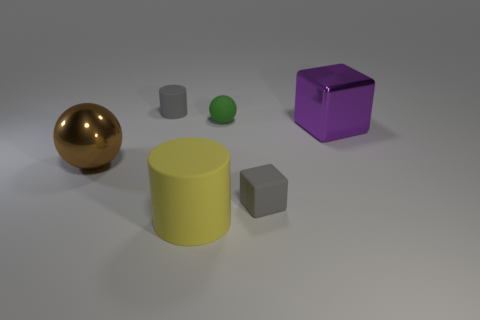Add 2 large yellow cylinders. How many objects exist? 8 Subtract all spheres. How many objects are left? 4 Subtract 0 red cubes. How many objects are left? 6 Subtract all brown metallic cubes. Subtract all large rubber objects. How many objects are left? 5 Add 1 big purple metal cubes. How many big purple metal cubes are left? 2 Add 2 large brown metallic things. How many large brown metallic things exist? 3 